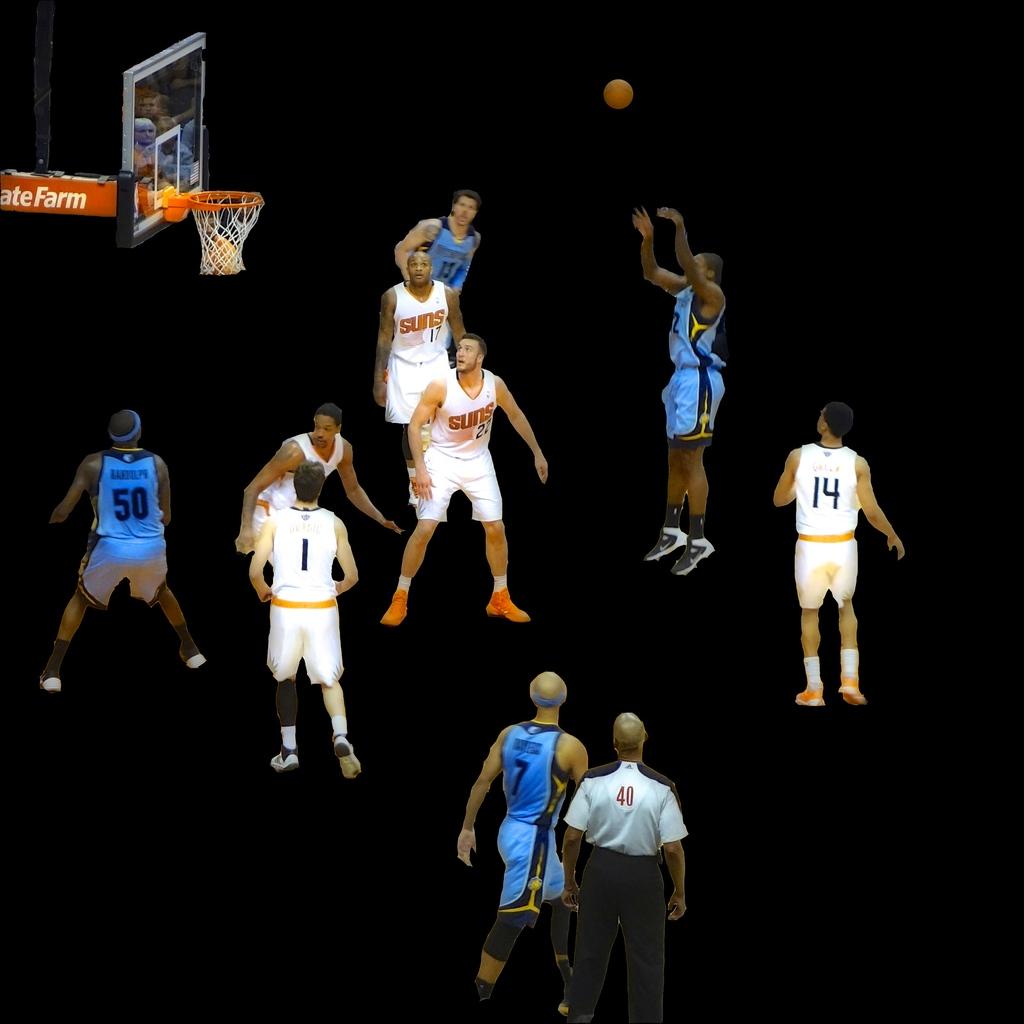Is number 14 on the court?
Make the answer very short. Yes. 